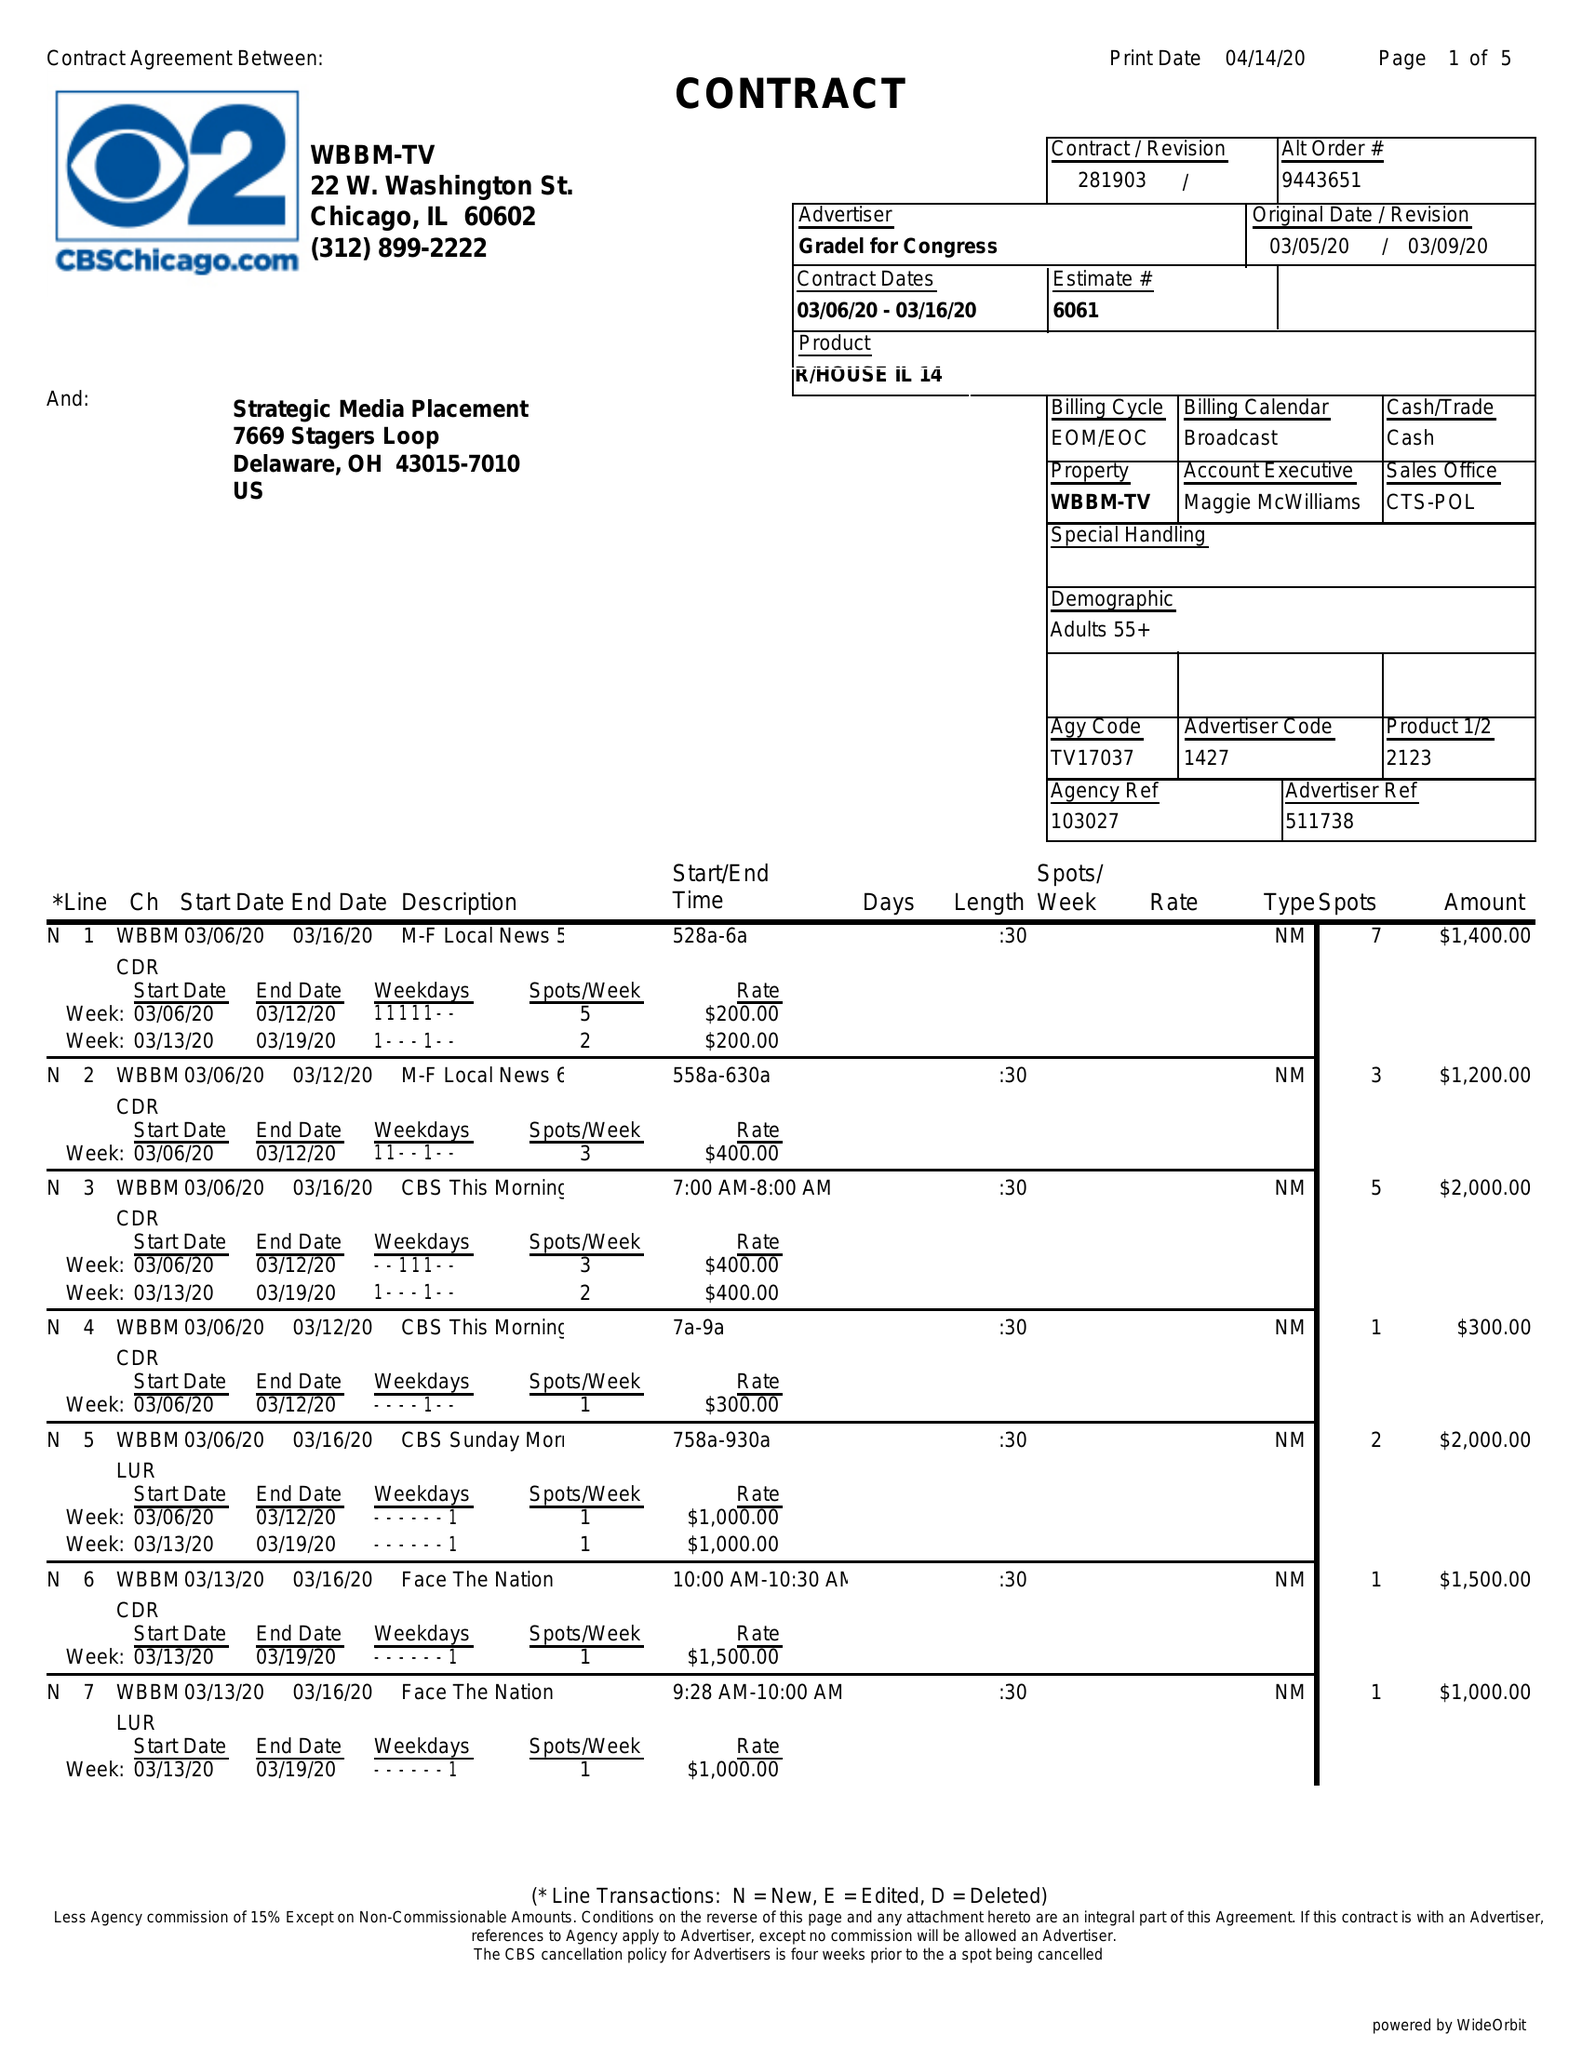What is the value for the flight_from?
Answer the question using a single word or phrase. 03/06/20 